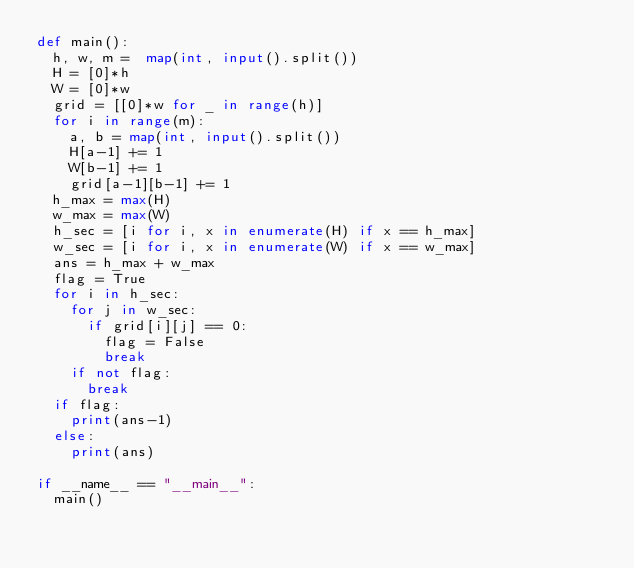Convert code to text. <code><loc_0><loc_0><loc_500><loc_500><_Python_>def main():
  h, w, m =  map(int, input().split())
  H = [0]*h
  W = [0]*w
  grid = [[0]*w for _ in range(h)]
  for i in range(m):
    a, b = map(int, input().split())
    H[a-1] += 1
    W[b-1] += 1
    grid[a-1][b-1] += 1
  h_max = max(H)
  w_max = max(W)
  h_sec = [i for i, x in enumerate(H) if x == h_max]
  w_sec = [i for i, x in enumerate(W) if x == w_max]
  ans = h_max + w_max
  flag = True
  for i in h_sec:
    for j in w_sec:
      if grid[i][j] == 0:
        flag = False
        break
    if not flag:
      break
  if flag:
    print(ans-1)
  else:
    print(ans)
  
if __name__ == "__main__":
  main()</code> 